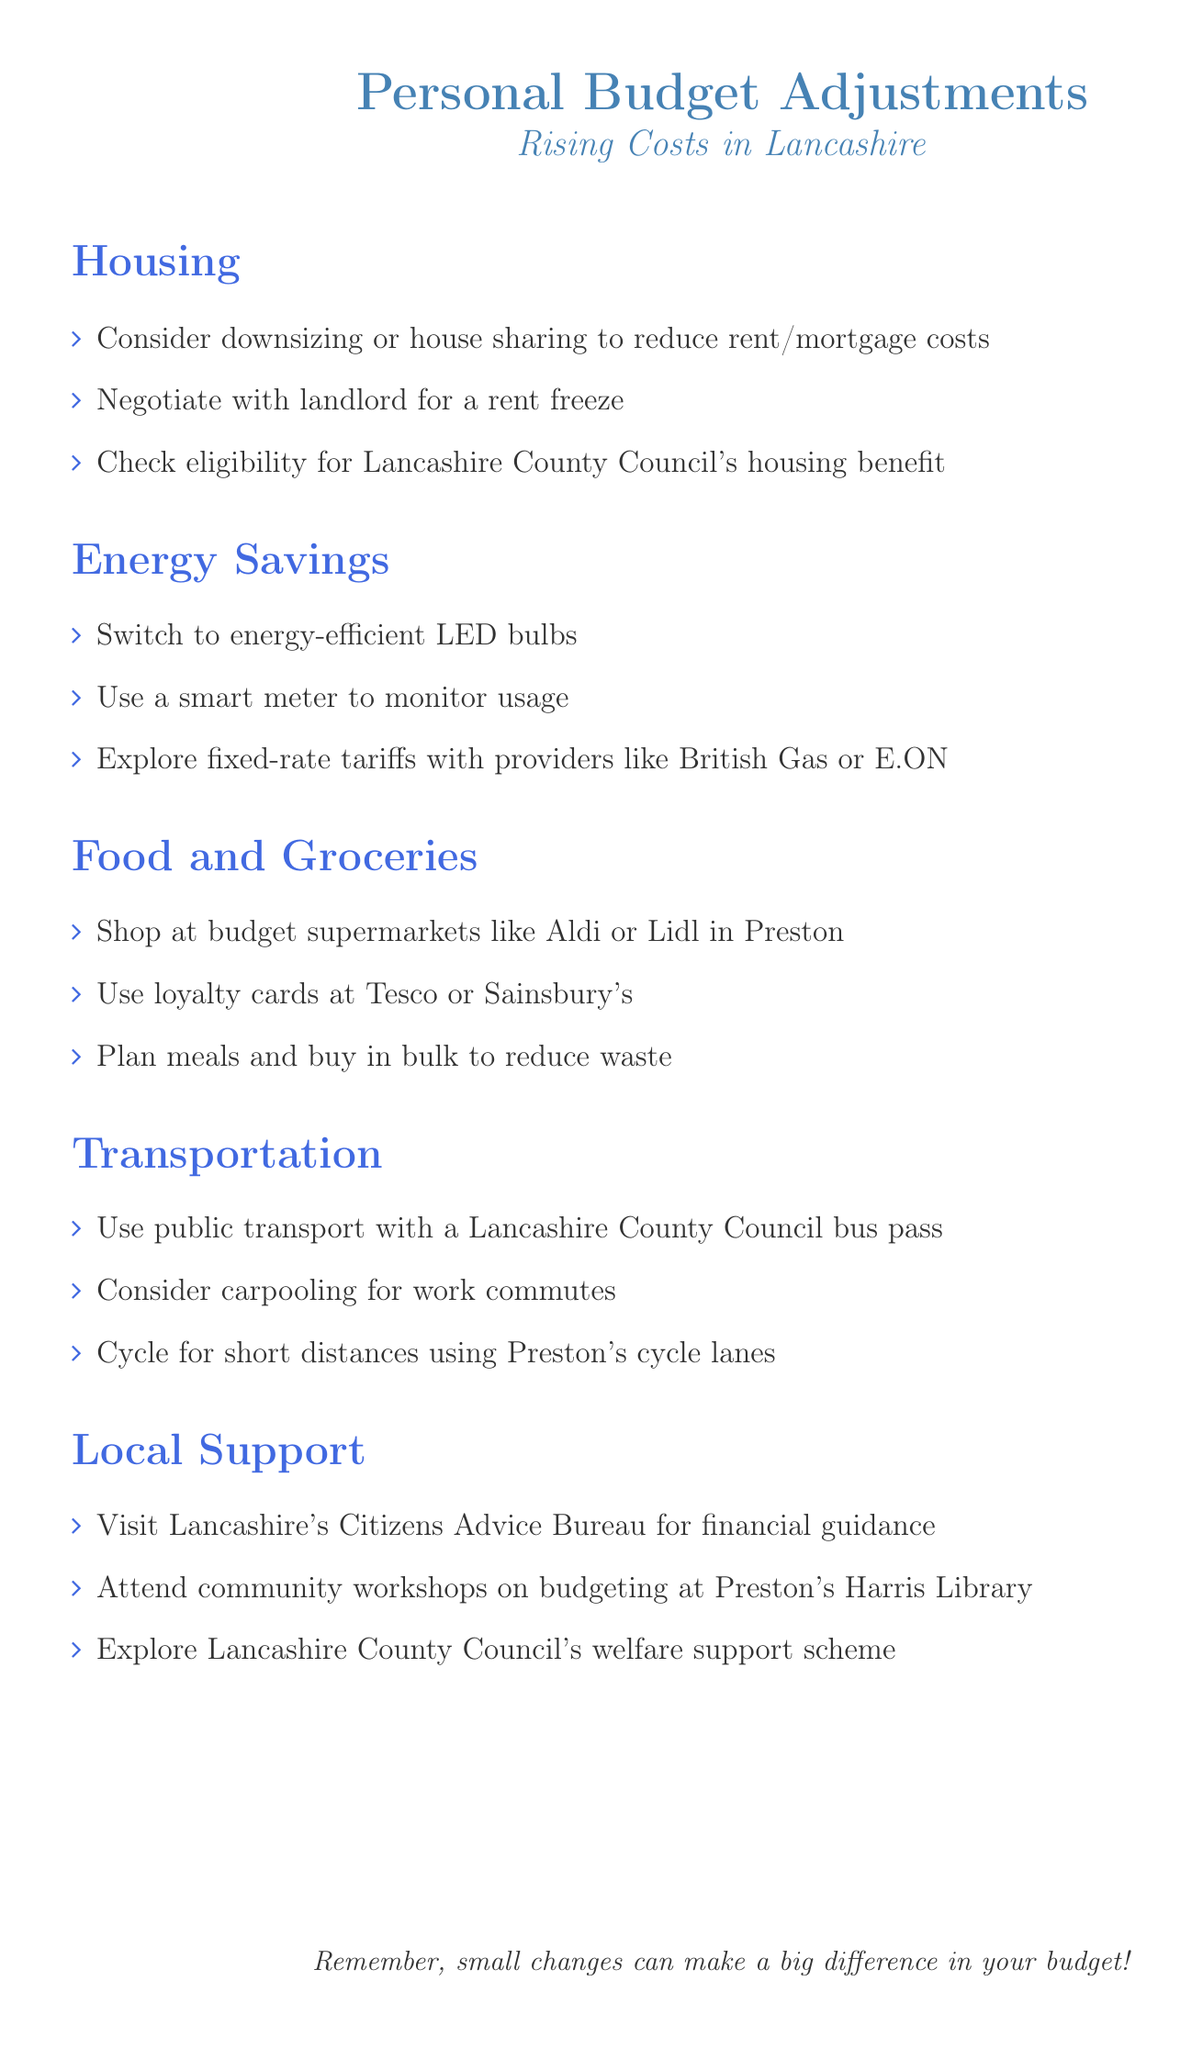What is one suggestion for housing adjustments? The document suggests considering downsizing or house sharing to reduce rent/mortgage costs.
Answer: Downsizing or house sharing How can residents save on energy costs? One suggestion is to switch to energy-efficient LED bulbs to cut down on energy costs.
Answer: Switch to energy-efficient LED bulbs What is a budget supermarket mentioned in the food and groceries section? The document lists Aldi as a budget supermarket where residents can shop for groceries.
Answer: Aldi What type of transport pass is suggested for public transport? The recommendations include using a Lancashire County Council bus pass for public transport savings.
Answer: Lancashire County Council bus pass Where can residents seek financial guidance locally? The document mentions visiting Lancashire's Citizens Advice Bureau for financial guidance.
Answer: Lancashire's Citizens Advice Bureau What is one way to reduce food waste according to the document? The document suggests planning meals and buying in bulk as a way to reduce food waste.
Answer: Plan meals and buy in bulk How can someone potentially save on their rent? Negotiating with the landlord for a rent freeze is a suggested approach to save on rent costs.
Answer: Negotiate for a rent freeze What is the focus of the local support section? The local support section focuses on community resources available for financial assistance and budgeting help.
Answer: Community resources for financial assistance What should one do to monitor energy usage? The document recommends using a smart meter to monitor energy usage effectively.
Answer: Use a smart meter 